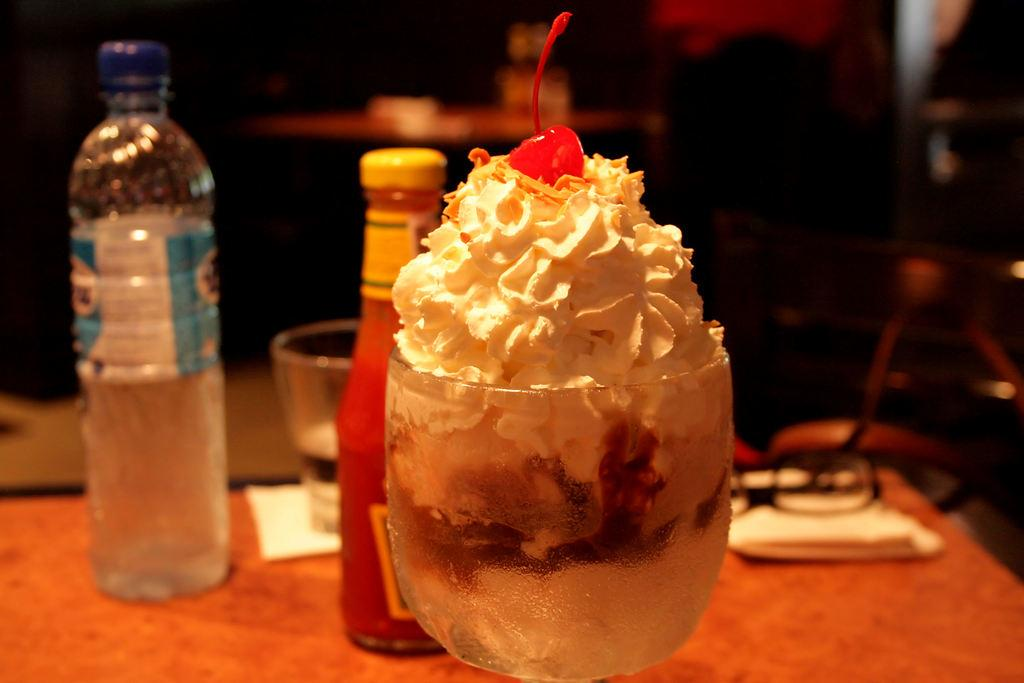What type of ice cream is shown in the image? There is an ice cream with cherry topping in the image. What other beverage container is present besides the ice cream? There is a water bottle in the image. What is the other drinking vessel in the image? There is a tumbler in the image. What condiment is visible in the image? There is a ketchup bottle in the image. Where are the objects placed in the image? The objects are placed on a table. What is another item present on the table? There is a pair of spectacles in the image. What type of sky can be seen in the image? There is no sky visible in the image; it is focused on objects placed on a table. Is there a park setting in the image? No, there is no park setting in the image; it features objects placed on a table. 